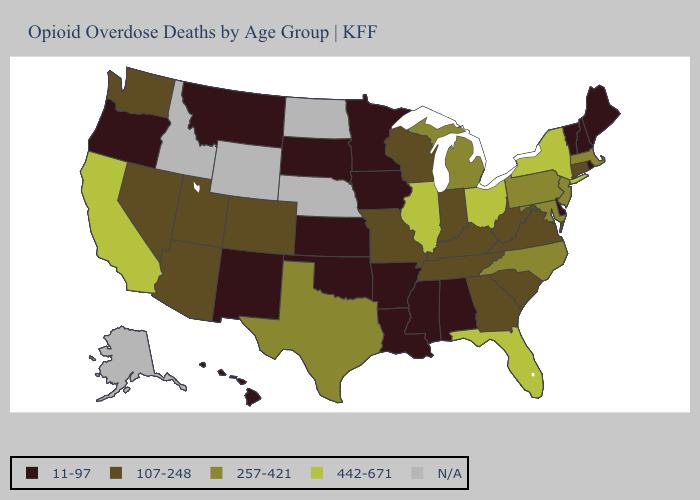What is the value of Tennessee?
Give a very brief answer. 107-248. Among the states that border Wisconsin , which have the highest value?
Quick response, please. Illinois. Name the states that have a value in the range 11-97?
Quick response, please. Alabama, Arkansas, Delaware, Hawaii, Iowa, Kansas, Louisiana, Maine, Minnesota, Mississippi, Montana, New Hampshire, New Mexico, Oklahoma, Oregon, Rhode Island, South Dakota, Vermont. Name the states that have a value in the range N/A?
Concise answer only. Alaska, Idaho, Nebraska, North Dakota, Wyoming. Among the states that border California , which have the highest value?
Give a very brief answer. Arizona, Nevada. Name the states that have a value in the range 257-421?
Keep it brief. Maryland, Massachusetts, Michigan, New Jersey, North Carolina, Pennsylvania, Texas. What is the lowest value in states that border Massachusetts?
Write a very short answer. 11-97. What is the lowest value in states that border Indiana?
Concise answer only. 107-248. Name the states that have a value in the range 257-421?
Quick response, please. Maryland, Massachusetts, Michigan, New Jersey, North Carolina, Pennsylvania, Texas. Name the states that have a value in the range 442-671?
Concise answer only. California, Florida, Illinois, New York, Ohio. Does California have the highest value in the West?
Quick response, please. Yes. Name the states that have a value in the range N/A?
Keep it brief. Alaska, Idaho, Nebraska, North Dakota, Wyoming. Does Vermont have the lowest value in the Northeast?
Write a very short answer. Yes. Among the states that border Ohio , which have the lowest value?
Be succinct. Indiana, Kentucky, West Virginia. 